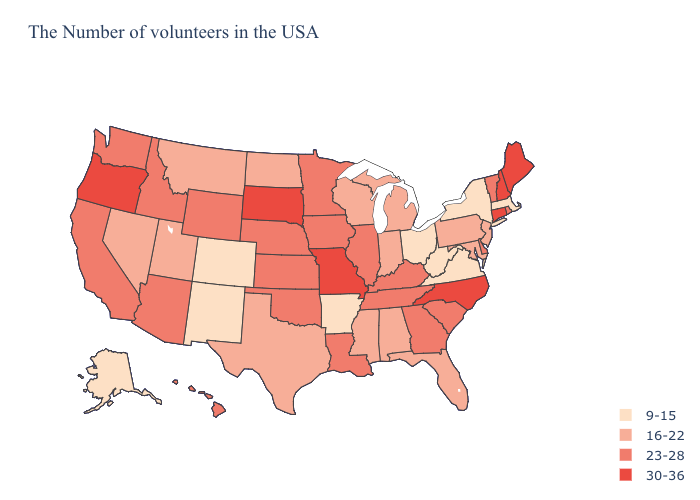Does Louisiana have a lower value than Texas?
Keep it brief. No. Name the states that have a value in the range 30-36?
Quick response, please. Maine, New Hampshire, Connecticut, North Carolina, Missouri, South Dakota, Oregon. Does the first symbol in the legend represent the smallest category?
Give a very brief answer. Yes. Does Idaho have the same value as South Dakota?
Keep it brief. No. What is the value of Arkansas?
Concise answer only. 9-15. Does North Dakota have the lowest value in the USA?
Give a very brief answer. No. Does Louisiana have a higher value than Idaho?
Answer briefly. No. Does Missouri have a lower value than Indiana?
Keep it brief. No. What is the value of New York?
Answer briefly. 9-15. Does the first symbol in the legend represent the smallest category?
Quick response, please. Yes. Name the states that have a value in the range 23-28?
Concise answer only. Rhode Island, Vermont, Delaware, South Carolina, Georgia, Kentucky, Tennessee, Illinois, Louisiana, Minnesota, Iowa, Kansas, Nebraska, Oklahoma, Wyoming, Arizona, Idaho, California, Washington, Hawaii. Which states have the lowest value in the USA?
Give a very brief answer. Massachusetts, New York, Virginia, West Virginia, Ohio, Arkansas, Colorado, New Mexico, Alaska. Name the states that have a value in the range 9-15?
Keep it brief. Massachusetts, New York, Virginia, West Virginia, Ohio, Arkansas, Colorado, New Mexico, Alaska. Does Louisiana have the highest value in the South?
Keep it brief. No. Among the states that border Ohio , which have the highest value?
Answer briefly. Kentucky. 